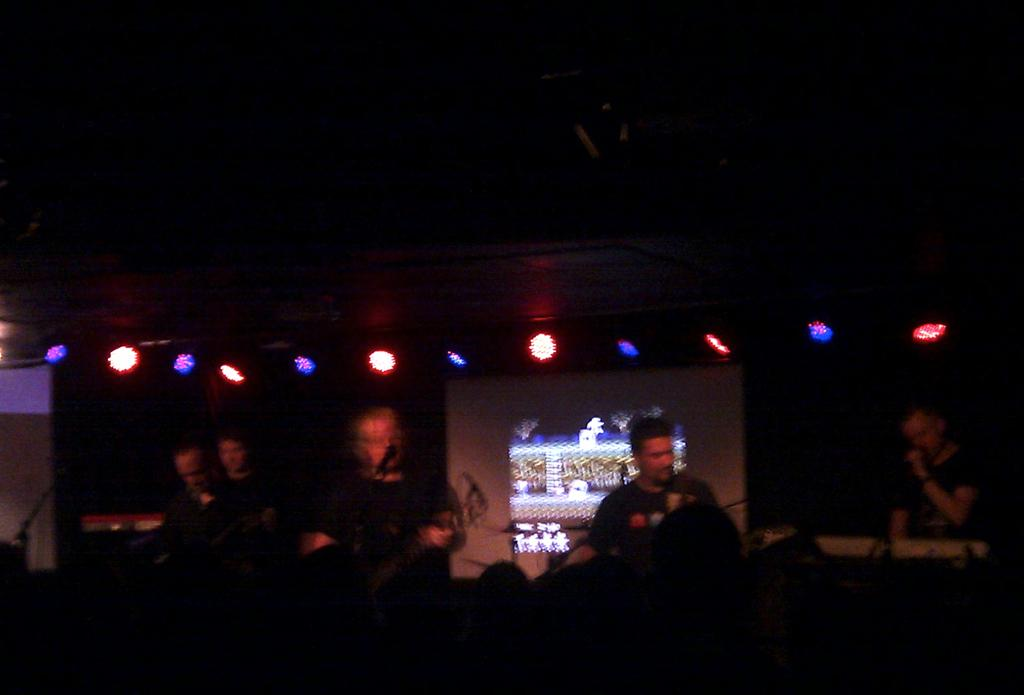What are the persons in the image doing? The persons in the image are playing musical instruments. What else can be seen in the image besides the musicians? There are lights visible in the image, as well as a screen. Is there any vocal performance happening in the image? Yes, one person is singing in the image. Where is the faucet located in the image? There is no faucet present in the image. What type of love is being expressed through the music in the image? The image does not convey any specific type of love; it simply shows people playing music and singing. 